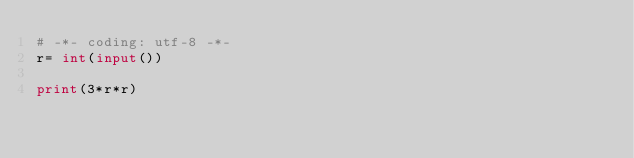<code> <loc_0><loc_0><loc_500><loc_500><_Python_># -*- coding: utf-8 -*-
r= int(input())

print(3*r*r)</code> 